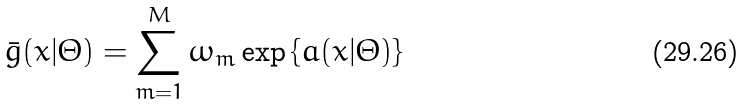Convert formula to latex. <formula><loc_0><loc_0><loc_500><loc_500>\bar { g } ( x | \Theta ) = \sum _ { m = 1 } ^ { M } \omega _ { m } \exp \left \{ a ( x | \Theta ) \right \}</formula> 